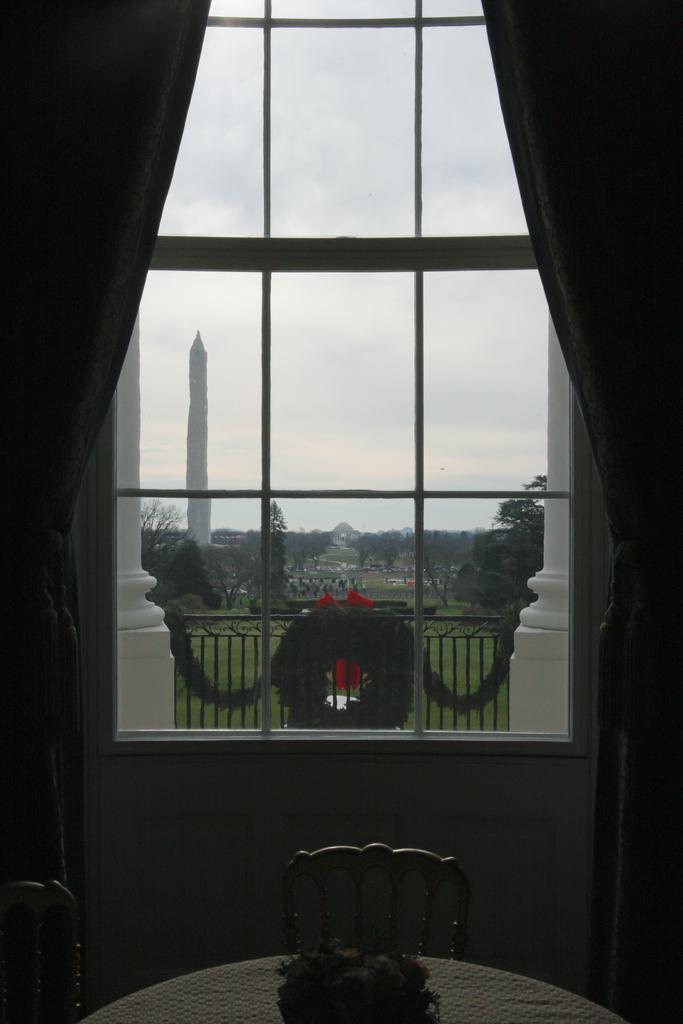How would you summarize this image in a sentence or two? In this image we can see a window, curtains and a wreath on the railing. On the backside we can see grass, a group of trees, buildings, a tower and the sky which looks cloudy. In the foreground we can see a basket on a table and some chairs. 